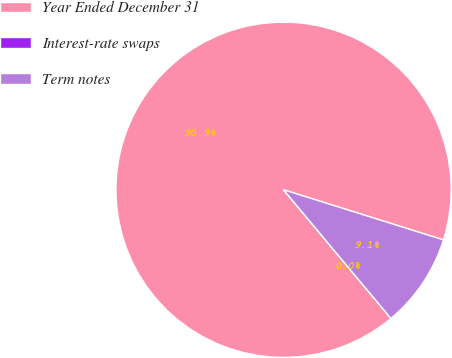Convert chart to OTSL. <chart><loc_0><loc_0><loc_500><loc_500><pie_chart><fcel>Year Ended December 31<fcel>Interest-rate swaps<fcel>Term notes<nl><fcel>90.9%<fcel>0.0%<fcel>9.09%<nl></chart> 